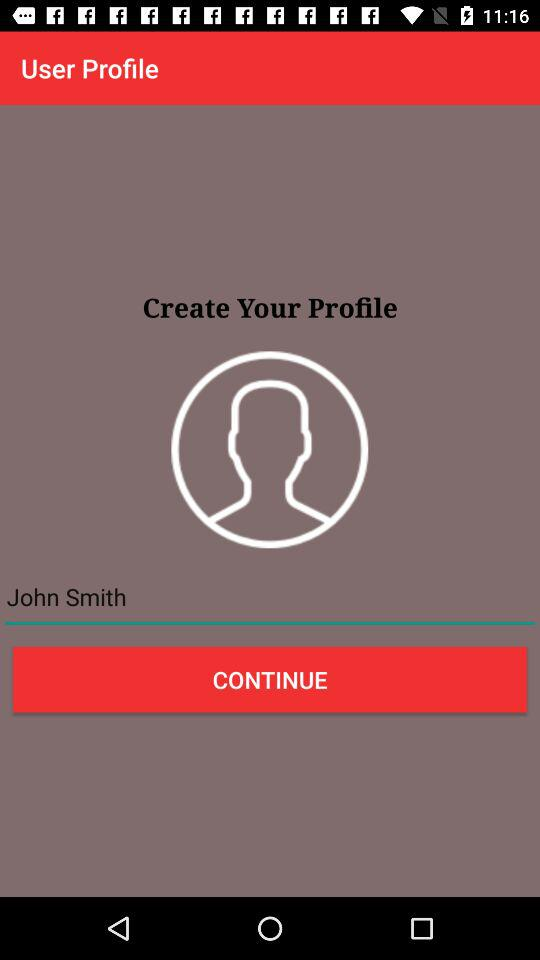How many types of security locks are available?
Answer the question using a single word or phrase. 3 